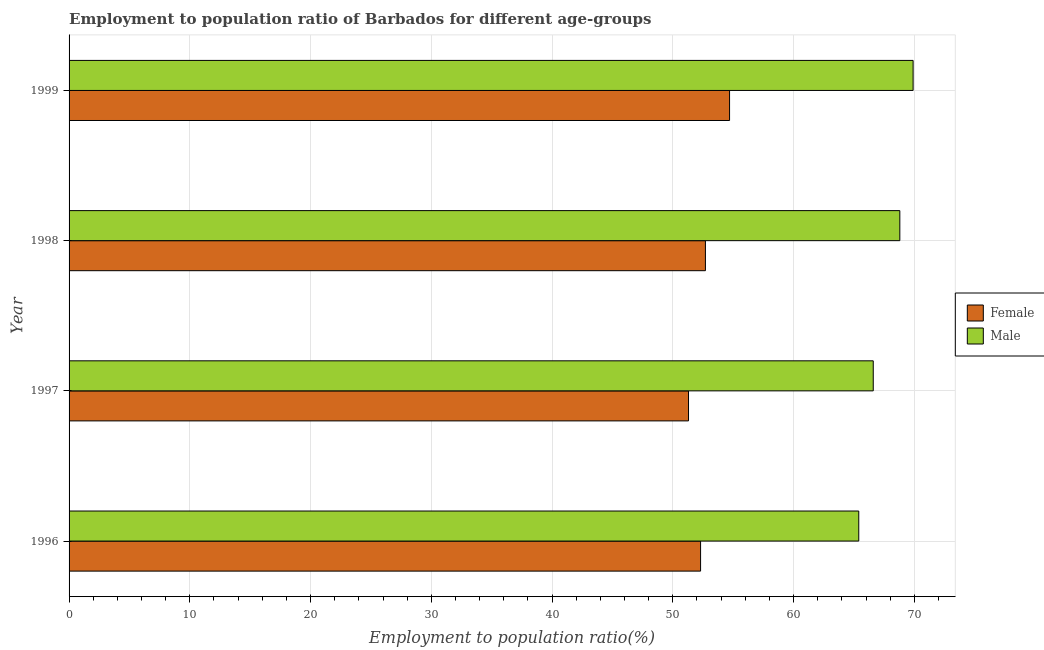How many different coloured bars are there?
Provide a short and direct response. 2. How many groups of bars are there?
Keep it short and to the point. 4. Are the number of bars per tick equal to the number of legend labels?
Offer a terse response. Yes. How many bars are there on the 4th tick from the top?
Offer a terse response. 2. What is the label of the 2nd group of bars from the top?
Your answer should be compact. 1998. In how many cases, is the number of bars for a given year not equal to the number of legend labels?
Keep it short and to the point. 0. What is the employment to population ratio(female) in 1999?
Your answer should be compact. 54.7. Across all years, what is the maximum employment to population ratio(male)?
Your answer should be compact. 69.9. Across all years, what is the minimum employment to population ratio(female)?
Your answer should be very brief. 51.3. In which year was the employment to population ratio(female) maximum?
Ensure brevity in your answer.  1999. In which year was the employment to population ratio(female) minimum?
Your answer should be compact. 1997. What is the total employment to population ratio(male) in the graph?
Your answer should be very brief. 270.7. What is the difference between the employment to population ratio(female) in 1998 and that in 1999?
Provide a succinct answer. -2. What is the difference between the employment to population ratio(male) in 1997 and the employment to population ratio(female) in 1999?
Provide a short and direct response. 11.9. What is the average employment to population ratio(male) per year?
Ensure brevity in your answer.  67.67. In the year 1998, what is the difference between the employment to population ratio(female) and employment to population ratio(male)?
Make the answer very short. -16.1. In how many years, is the employment to population ratio(male) greater than 6 %?
Ensure brevity in your answer.  4. Is the difference between the employment to population ratio(male) in 1997 and 1998 greater than the difference between the employment to population ratio(female) in 1997 and 1998?
Your answer should be very brief. No. What is the difference between the highest and the lowest employment to population ratio(male)?
Your answer should be very brief. 4.5. In how many years, is the employment to population ratio(male) greater than the average employment to population ratio(male) taken over all years?
Offer a very short reply. 2. Is the sum of the employment to population ratio(male) in 1996 and 1997 greater than the maximum employment to population ratio(female) across all years?
Your answer should be compact. Yes. What does the 2nd bar from the bottom in 1999 represents?
Your response must be concise. Male. What is the difference between two consecutive major ticks on the X-axis?
Provide a short and direct response. 10. Are the values on the major ticks of X-axis written in scientific E-notation?
Provide a short and direct response. No. Does the graph contain grids?
Provide a succinct answer. Yes. How are the legend labels stacked?
Provide a succinct answer. Vertical. What is the title of the graph?
Your answer should be very brief. Employment to population ratio of Barbados for different age-groups. Does "Money lenders" appear as one of the legend labels in the graph?
Keep it short and to the point. No. What is the Employment to population ratio(%) in Female in 1996?
Your answer should be compact. 52.3. What is the Employment to population ratio(%) in Male in 1996?
Give a very brief answer. 65.4. What is the Employment to population ratio(%) in Female in 1997?
Provide a succinct answer. 51.3. What is the Employment to population ratio(%) in Male in 1997?
Provide a succinct answer. 66.6. What is the Employment to population ratio(%) of Female in 1998?
Your answer should be compact. 52.7. What is the Employment to population ratio(%) of Male in 1998?
Make the answer very short. 68.8. What is the Employment to population ratio(%) of Female in 1999?
Keep it short and to the point. 54.7. What is the Employment to population ratio(%) of Male in 1999?
Provide a succinct answer. 69.9. Across all years, what is the maximum Employment to population ratio(%) of Female?
Your answer should be very brief. 54.7. Across all years, what is the maximum Employment to population ratio(%) of Male?
Give a very brief answer. 69.9. Across all years, what is the minimum Employment to population ratio(%) in Female?
Make the answer very short. 51.3. Across all years, what is the minimum Employment to population ratio(%) in Male?
Ensure brevity in your answer.  65.4. What is the total Employment to population ratio(%) of Female in the graph?
Provide a short and direct response. 211. What is the total Employment to population ratio(%) of Male in the graph?
Your response must be concise. 270.7. What is the difference between the Employment to population ratio(%) of Female in 1996 and that in 1997?
Ensure brevity in your answer.  1. What is the difference between the Employment to population ratio(%) of Male in 1996 and that in 1998?
Give a very brief answer. -3.4. What is the difference between the Employment to population ratio(%) in Female in 1996 and that in 1999?
Provide a short and direct response. -2.4. What is the difference between the Employment to population ratio(%) of Male in 1996 and that in 1999?
Provide a succinct answer. -4.5. What is the difference between the Employment to population ratio(%) of Female in 1997 and that in 1998?
Offer a very short reply. -1.4. What is the difference between the Employment to population ratio(%) in Male in 1997 and that in 1998?
Your answer should be compact. -2.2. What is the difference between the Employment to population ratio(%) in Male in 1998 and that in 1999?
Ensure brevity in your answer.  -1.1. What is the difference between the Employment to population ratio(%) of Female in 1996 and the Employment to population ratio(%) of Male in 1997?
Give a very brief answer. -14.3. What is the difference between the Employment to population ratio(%) in Female in 1996 and the Employment to population ratio(%) in Male in 1998?
Offer a terse response. -16.5. What is the difference between the Employment to population ratio(%) of Female in 1996 and the Employment to population ratio(%) of Male in 1999?
Your answer should be very brief. -17.6. What is the difference between the Employment to population ratio(%) of Female in 1997 and the Employment to population ratio(%) of Male in 1998?
Provide a succinct answer. -17.5. What is the difference between the Employment to population ratio(%) of Female in 1997 and the Employment to population ratio(%) of Male in 1999?
Give a very brief answer. -18.6. What is the difference between the Employment to population ratio(%) of Female in 1998 and the Employment to population ratio(%) of Male in 1999?
Your answer should be very brief. -17.2. What is the average Employment to population ratio(%) of Female per year?
Your answer should be compact. 52.75. What is the average Employment to population ratio(%) of Male per year?
Your response must be concise. 67.67. In the year 1997, what is the difference between the Employment to population ratio(%) in Female and Employment to population ratio(%) in Male?
Provide a short and direct response. -15.3. In the year 1998, what is the difference between the Employment to population ratio(%) in Female and Employment to population ratio(%) in Male?
Your response must be concise. -16.1. In the year 1999, what is the difference between the Employment to population ratio(%) in Female and Employment to population ratio(%) in Male?
Your answer should be compact. -15.2. What is the ratio of the Employment to population ratio(%) in Female in 1996 to that in 1997?
Offer a very short reply. 1.02. What is the ratio of the Employment to population ratio(%) of Male in 1996 to that in 1998?
Keep it short and to the point. 0.95. What is the ratio of the Employment to population ratio(%) in Female in 1996 to that in 1999?
Ensure brevity in your answer.  0.96. What is the ratio of the Employment to population ratio(%) of Male in 1996 to that in 1999?
Your answer should be compact. 0.94. What is the ratio of the Employment to population ratio(%) in Female in 1997 to that in 1998?
Ensure brevity in your answer.  0.97. What is the ratio of the Employment to population ratio(%) of Male in 1997 to that in 1998?
Your response must be concise. 0.97. What is the ratio of the Employment to population ratio(%) of Female in 1997 to that in 1999?
Make the answer very short. 0.94. What is the ratio of the Employment to population ratio(%) of Male in 1997 to that in 1999?
Give a very brief answer. 0.95. What is the ratio of the Employment to population ratio(%) of Female in 1998 to that in 1999?
Keep it short and to the point. 0.96. What is the ratio of the Employment to population ratio(%) of Male in 1998 to that in 1999?
Give a very brief answer. 0.98. What is the difference between the highest and the second highest Employment to population ratio(%) in Male?
Your answer should be compact. 1.1. What is the difference between the highest and the lowest Employment to population ratio(%) in Female?
Keep it short and to the point. 3.4. What is the difference between the highest and the lowest Employment to population ratio(%) in Male?
Give a very brief answer. 4.5. 